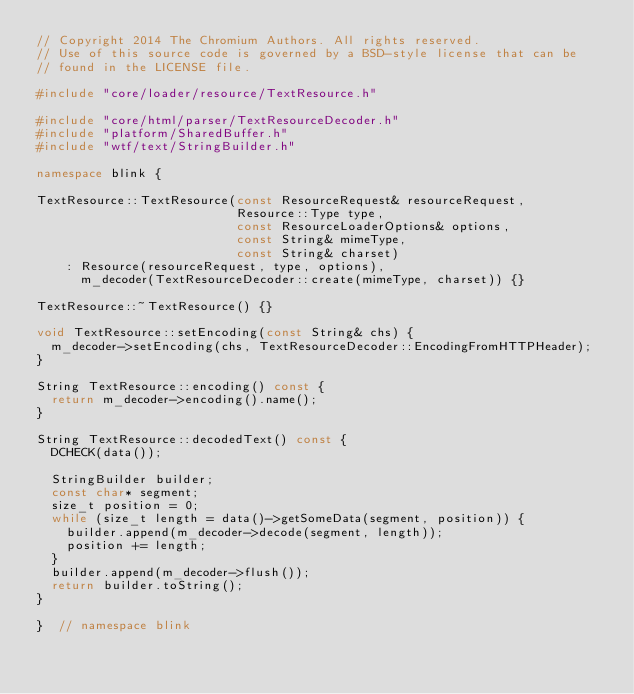Convert code to text. <code><loc_0><loc_0><loc_500><loc_500><_C++_>// Copyright 2014 The Chromium Authors. All rights reserved.
// Use of this source code is governed by a BSD-style license that can be
// found in the LICENSE file.

#include "core/loader/resource/TextResource.h"

#include "core/html/parser/TextResourceDecoder.h"
#include "platform/SharedBuffer.h"
#include "wtf/text/StringBuilder.h"

namespace blink {

TextResource::TextResource(const ResourceRequest& resourceRequest,
                           Resource::Type type,
                           const ResourceLoaderOptions& options,
                           const String& mimeType,
                           const String& charset)
    : Resource(resourceRequest, type, options),
      m_decoder(TextResourceDecoder::create(mimeType, charset)) {}

TextResource::~TextResource() {}

void TextResource::setEncoding(const String& chs) {
  m_decoder->setEncoding(chs, TextResourceDecoder::EncodingFromHTTPHeader);
}

String TextResource::encoding() const {
  return m_decoder->encoding().name();
}

String TextResource::decodedText() const {
  DCHECK(data());

  StringBuilder builder;
  const char* segment;
  size_t position = 0;
  while (size_t length = data()->getSomeData(segment, position)) {
    builder.append(m_decoder->decode(segment, length));
    position += length;
  }
  builder.append(m_decoder->flush());
  return builder.toString();
}

}  // namespace blink
</code> 